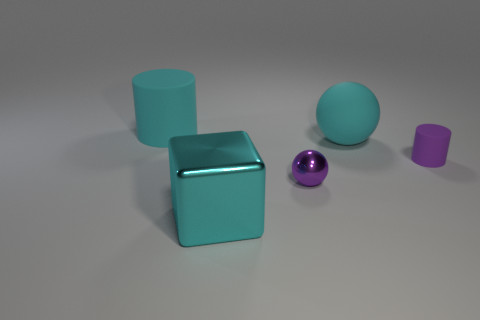Add 5 tiny purple metal balls. How many objects exist? 10 Subtract all cubes. How many objects are left? 4 Subtract all green metal spheres. Subtract all large metallic things. How many objects are left? 4 Add 4 purple matte cylinders. How many purple matte cylinders are left? 5 Add 2 big cyan metal blocks. How many big cyan metal blocks exist? 3 Subtract 0 red spheres. How many objects are left? 5 